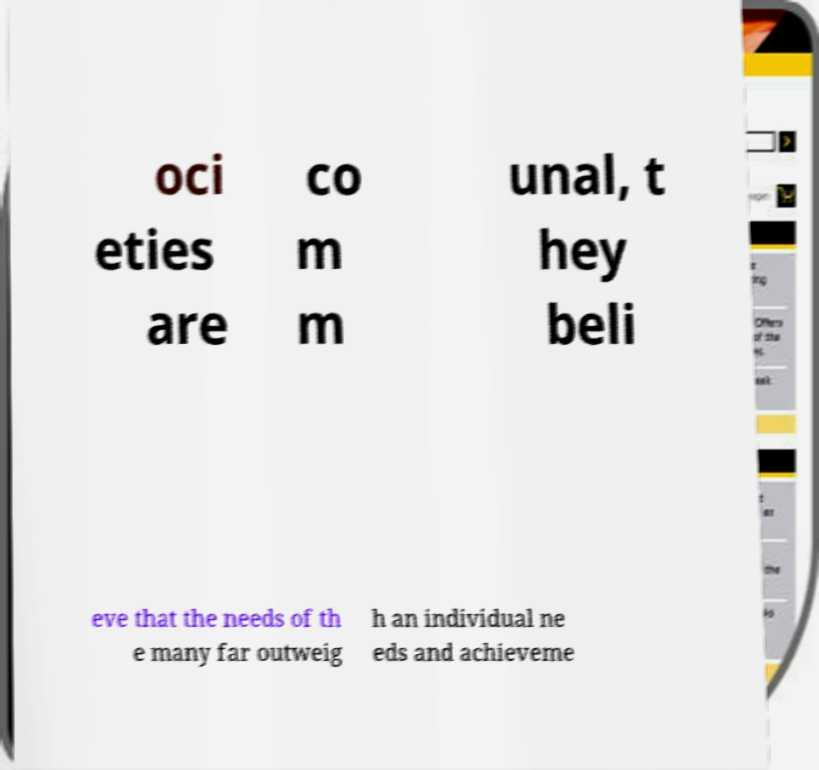Please identify and transcribe the text found in this image. oci eties are co m m unal, t hey beli eve that the needs of th e many far outweig h an individual ne eds and achieveme 